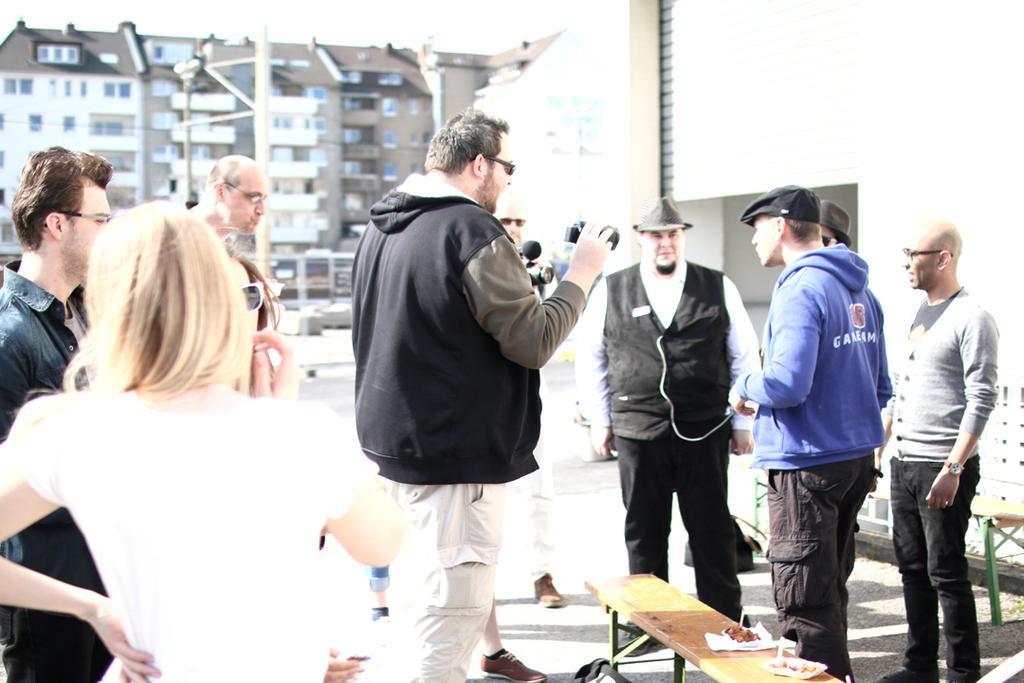Please provide a concise description of this image. In the image we can see few persons were standing,the center person he is holding camera. In the background there is a building and sky. 